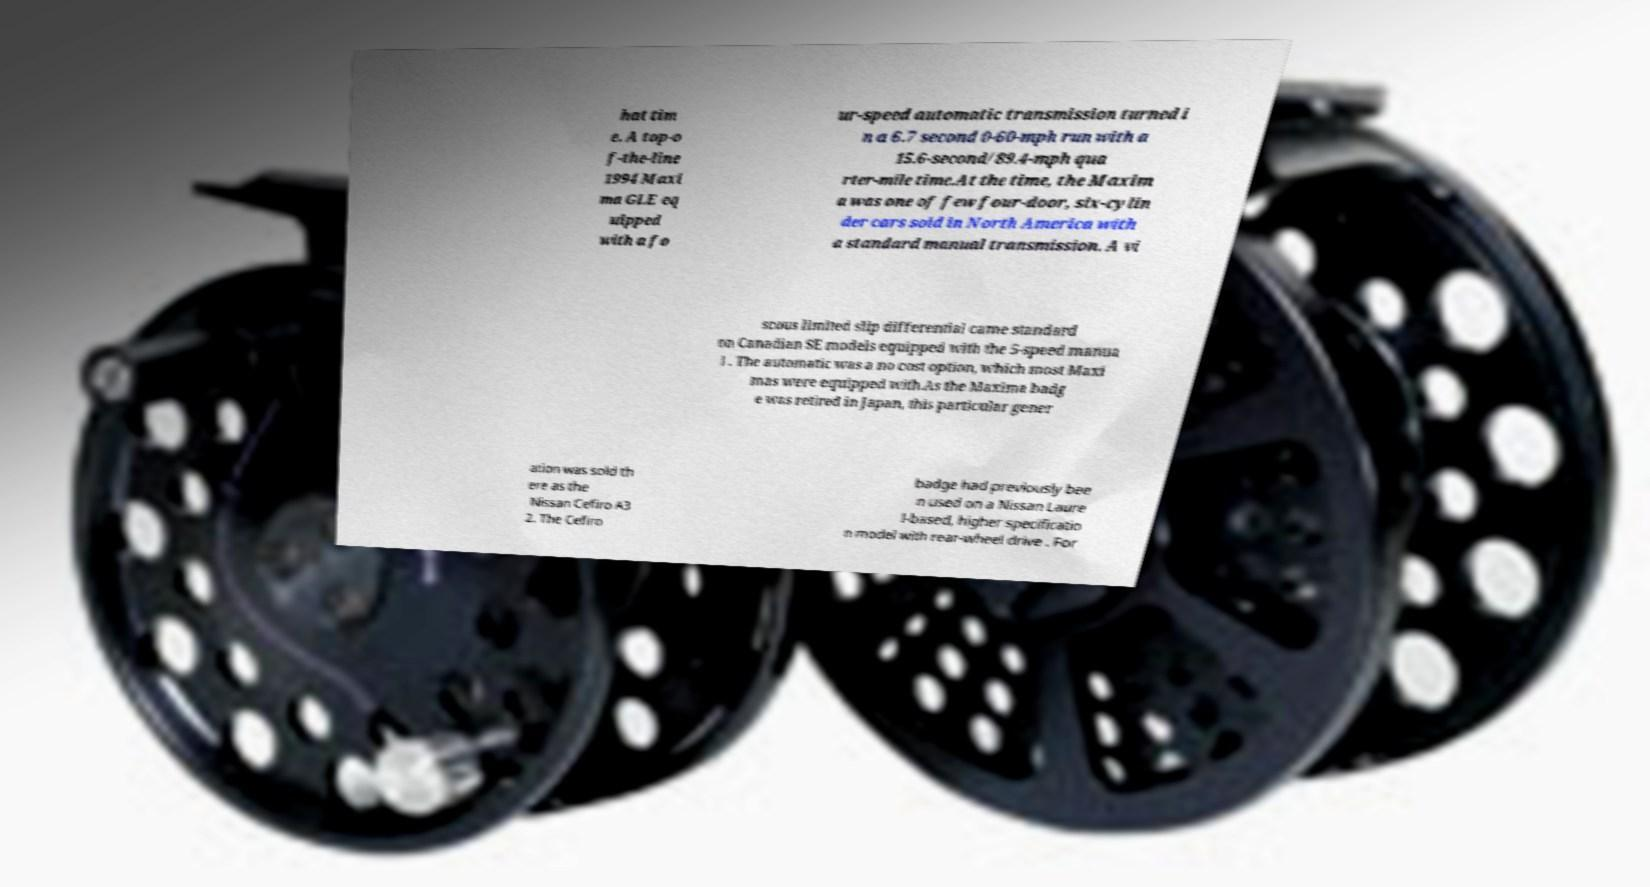Could you extract and type out the text from this image? hat tim e. A top-o f-the-line 1994 Maxi ma GLE eq uipped with a fo ur-speed automatic transmission turned i n a 6.7 second 0-60-mph run with a 15.6-second/89.4-mph qua rter-mile time.At the time, the Maxim a was one of few four-door, six-cylin der cars sold in North America with a standard manual transmission. A vi scous limited slip differential came standard on Canadian SE models equipped with the 5-speed manua l . The automatic was a no cost option, which most Maxi mas were equipped with.As the Maxima badg e was retired in Japan, this particular gener ation was sold th ere as the Nissan Cefiro A3 2. The Cefiro badge had previously bee n used on a Nissan Laure l-based, higher specificatio n model with rear-wheel drive . For 